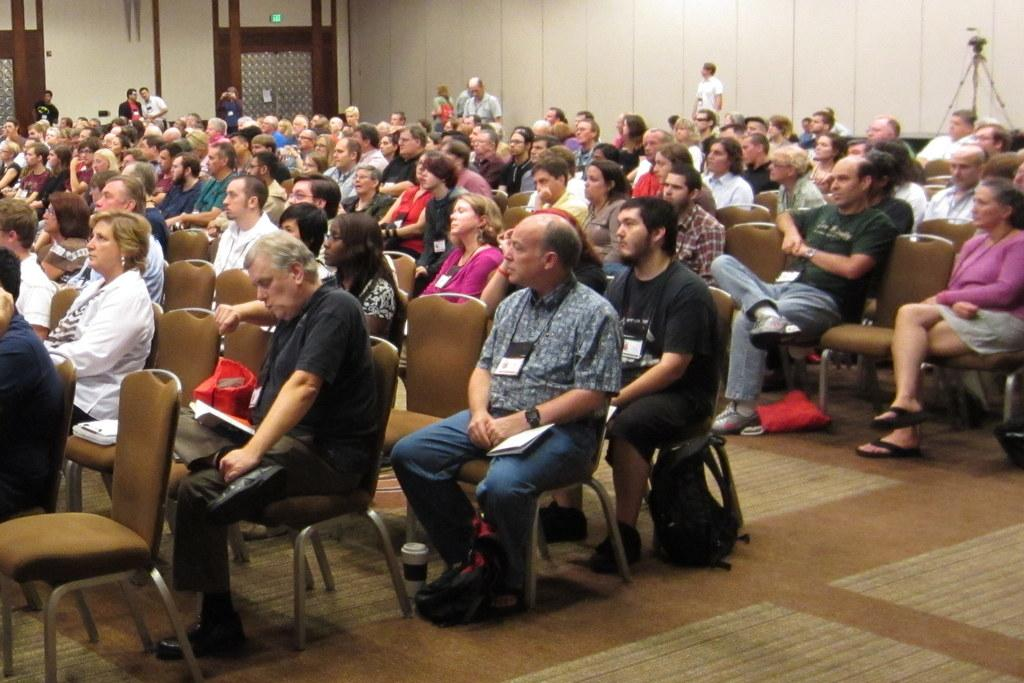What are the persons in the image doing? The persons in the image are sitting on chairs and standing on the floor. What object can be seen in the image besides the chairs and persons? There is a bag in the image. What is visible beneath the persons and the bag? The floor is visible in the image. What is the background of the image? There is a wall in the image. What type of mine can be seen in the image? There is no mine present in the image. What metal is used to construct the chairs in the image? The image does not provide information about the material used to construct the chairs. 